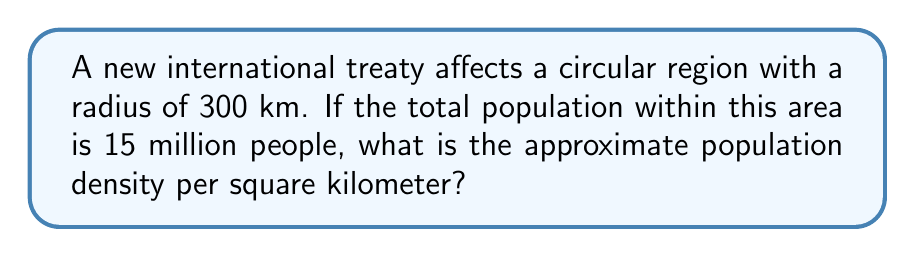Teach me how to tackle this problem. To solve this problem, we need to follow these steps:

1. Calculate the area of the circular region:
   The formula for the area of a circle is $A = \pi r^2$, where $r$ is the radius.
   
   $$A = \pi (300 \text{ km})^2 = 282,743.34 \text{ km}^2$$

2. Calculate the population density:
   Population density is defined as the total population divided by the area.
   
   $$\text{Population Density} = \frac{\text{Total Population}}{\text{Area}}$$

   $$\text{Population Density} = \frac{15,000,000 \text{ people}}{282,743.34 \text{ km}^2}$$

3. Perform the division:
   
   $$\text{Population Density} \approx 53.05 \text{ people/km}^2$$

4. Round to a reasonable number of significant figures:
   Given the nature of population estimates, rounding to two significant figures is appropriate.

   $$\text{Population Density} \approx 53 \text{ people/km}^2$$
Answer: 53 people/km² 